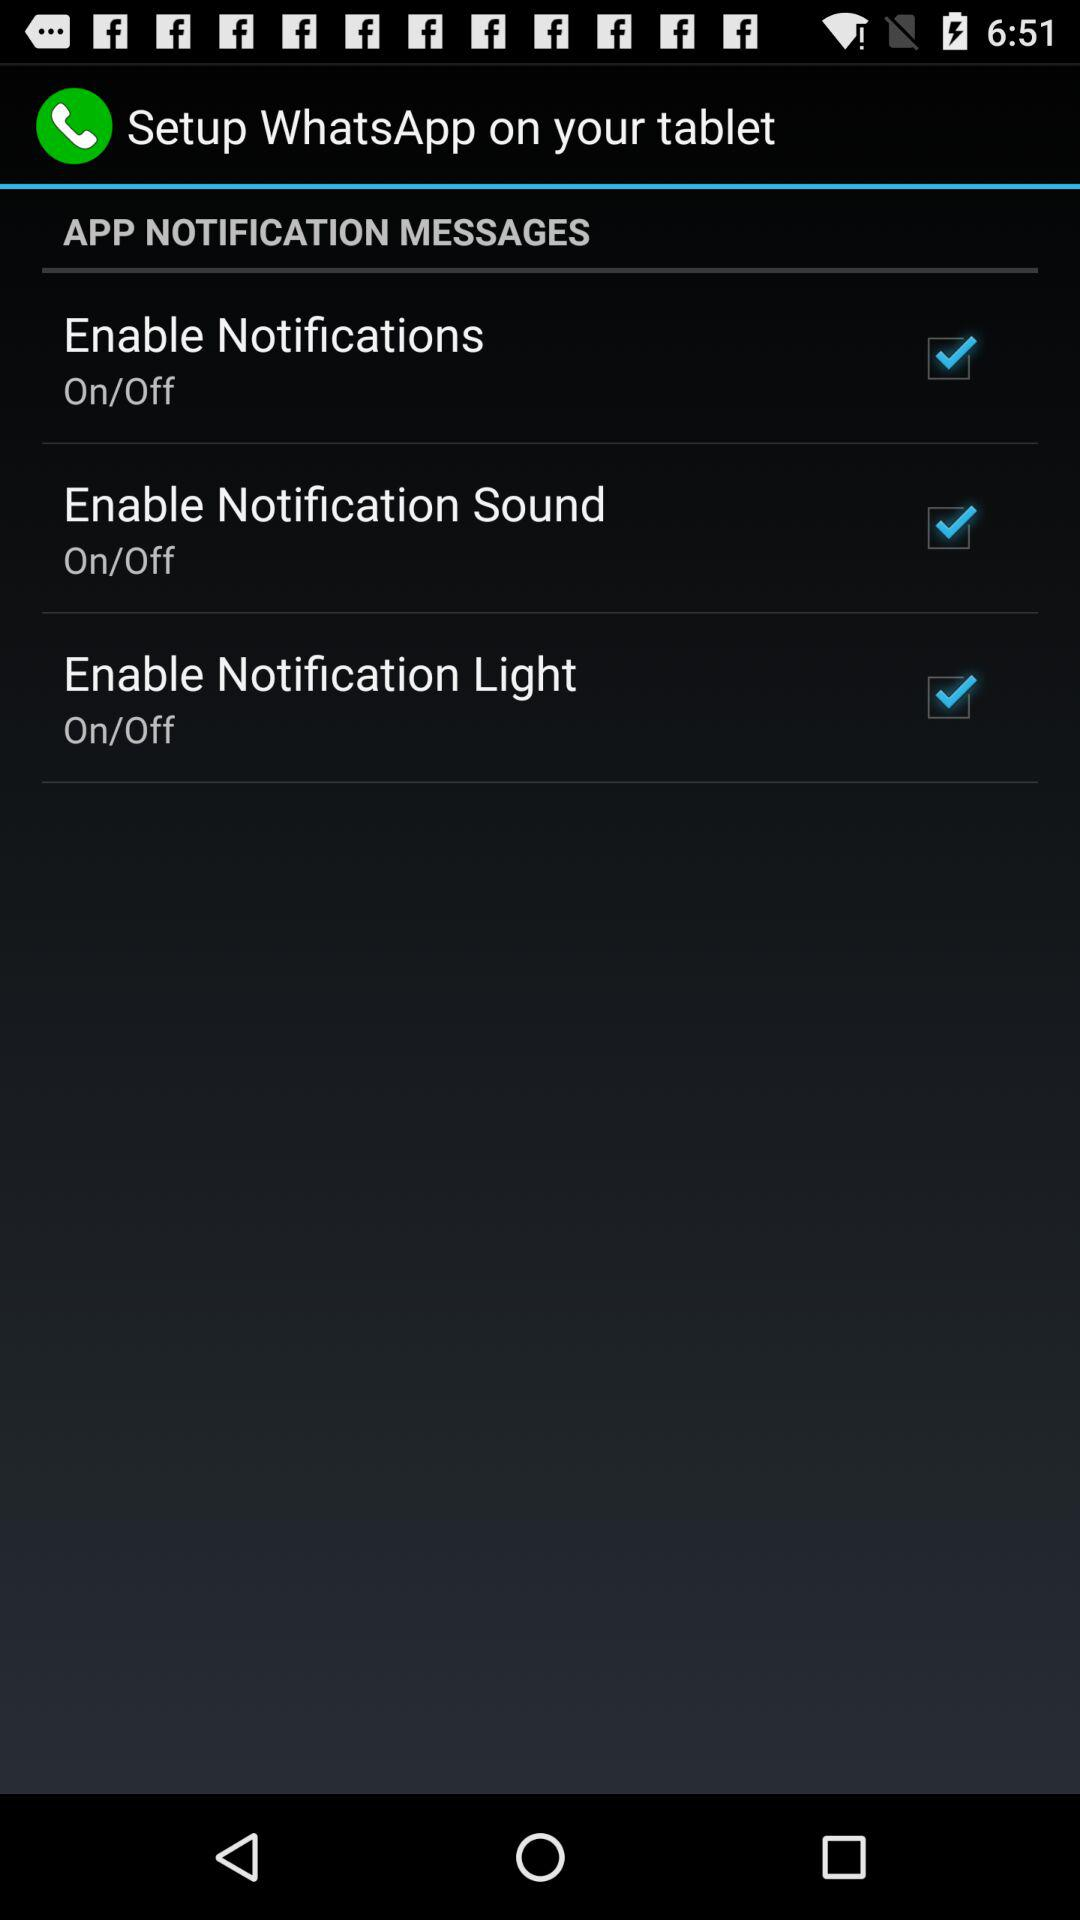Which notifications are on? The notifications are "Enable Notifications", "Enable Notification Sound" and "Enable Notification Light". 